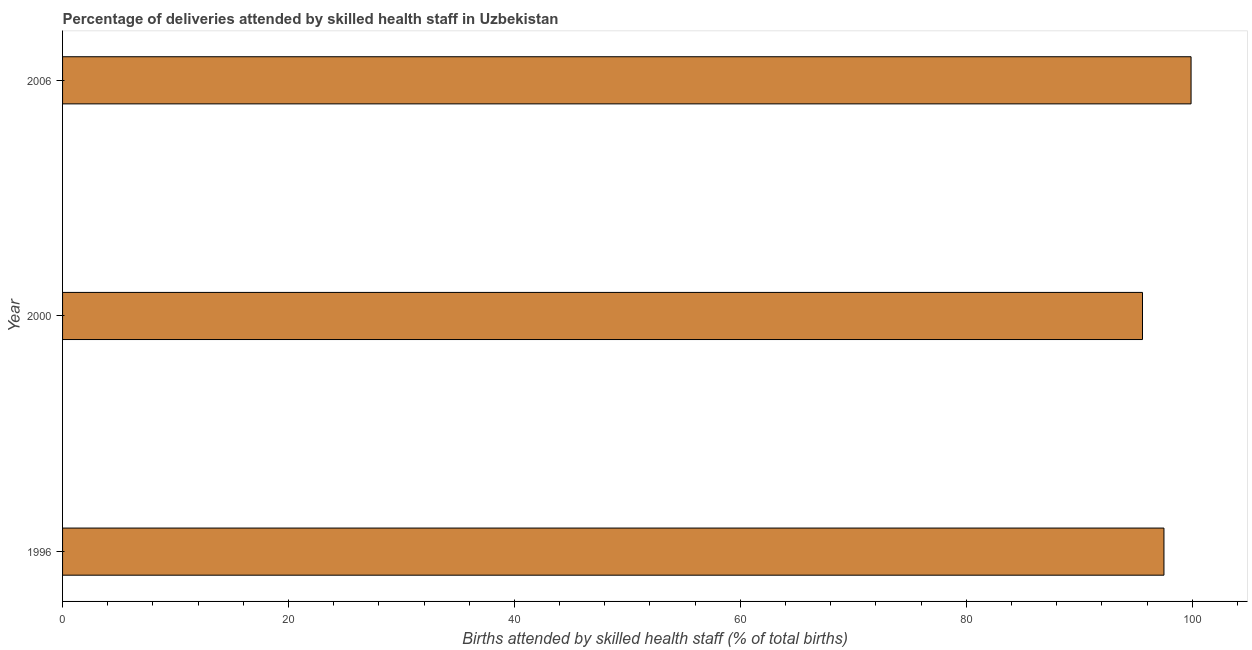What is the title of the graph?
Your answer should be very brief. Percentage of deliveries attended by skilled health staff in Uzbekistan. What is the label or title of the X-axis?
Give a very brief answer. Births attended by skilled health staff (% of total births). What is the label or title of the Y-axis?
Make the answer very short. Year. What is the number of births attended by skilled health staff in 2000?
Your answer should be compact. 95.6. Across all years, what is the maximum number of births attended by skilled health staff?
Offer a very short reply. 99.9. Across all years, what is the minimum number of births attended by skilled health staff?
Offer a very short reply. 95.6. In which year was the number of births attended by skilled health staff maximum?
Your response must be concise. 2006. In which year was the number of births attended by skilled health staff minimum?
Offer a very short reply. 2000. What is the sum of the number of births attended by skilled health staff?
Give a very brief answer. 293. What is the difference between the number of births attended by skilled health staff in 2000 and 2006?
Offer a terse response. -4.3. What is the average number of births attended by skilled health staff per year?
Offer a terse response. 97.67. What is the median number of births attended by skilled health staff?
Your answer should be very brief. 97.5. In how many years, is the number of births attended by skilled health staff greater than 12 %?
Offer a very short reply. 3. Do a majority of the years between 2000 and 1996 (inclusive) have number of births attended by skilled health staff greater than 68 %?
Provide a short and direct response. No. What is the difference between the highest and the lowest number of births attended by skilled health staff?
Give a very brief answer. 4.3. In how many years, is the number of births attended by skilled health staff greater than the average number of births attended by skilled health staff taken over all years?
Make the answer very short. 1. How many bars are there?
Your response must be concise. 3. What is the difference between two consecutive major ticks on the X-axis?
Ensure brevity in your answer.  20. Are the values on the major ticks of X-axis written in scientific E-notation?
Provide a short and direct response. No. What is the Births attended by skilled health staff (% of total births) in 1996?
Your response must be concise. 97.5. What is the Births attended by skilled health staff (% of total births) of 2000?
Your answer should be compact. 95.6. What is the Births attended by skilled health staff (% of total births) of 2006?
Offer a terse response. 99.9. What is the difference between the Births attended by skilled health staff (% of total births) in 1996 and 2000?
Provide a succinct answer. 1.9. What is the difference between the Births attended by skilled health staff (% of total births) in 1996 and 2006?
Provide a short and direct response. -2.4. What is the difference between the Births attended by skilled health staff (% of total births) in 2000 and 2006?
Your answer should be very brief. -4.3. What is the ratio of the Births attended by skilled health staff (% of total births) in 1996 to that in 2000?
Make the answer very short. 1.02. 